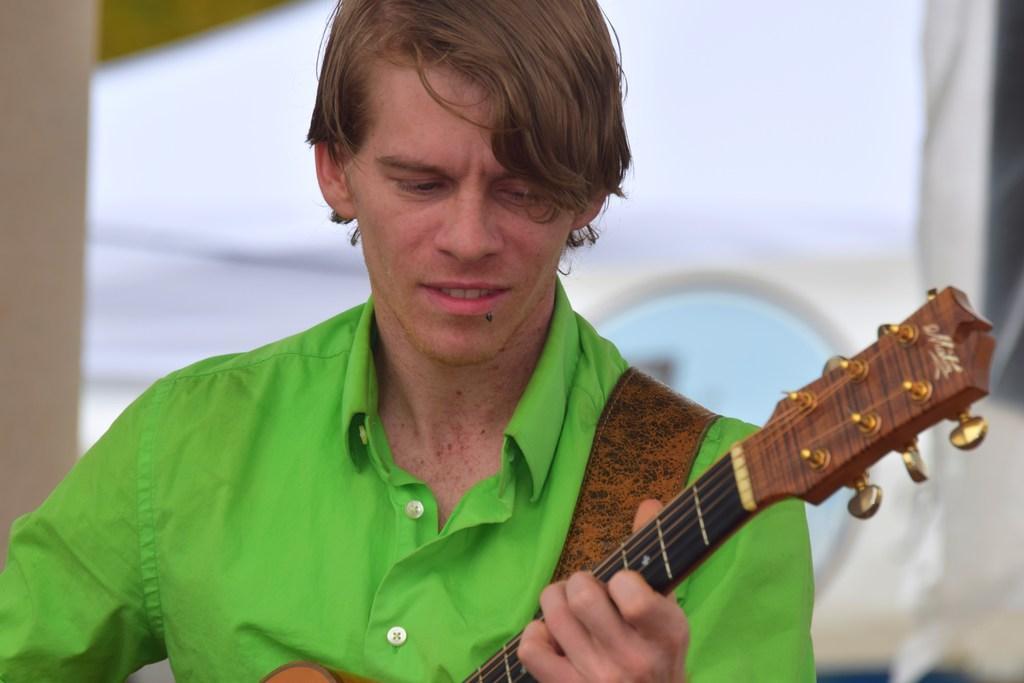How would you summarize this image in a sentence or two? This person holding guitar. On the background we can see wall. 